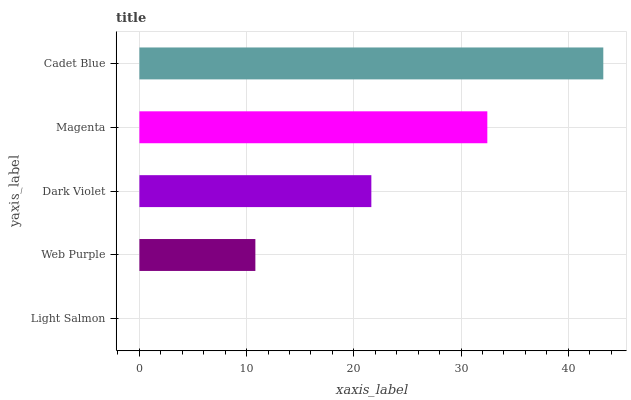Is Light Salmon the minimum?
Answer yes or no. Yes. Is Cadet Blue the maximum?
Answer yes or no. Yes. Is Web Purple the minimum?
Answer yes or no. No. Is Web Purple the maximum?
Answer yes or no. No. Is Web Purple greater than Light Salmon?
Answer yes or no. Yes. Is Light Salmon less than Web Purple?
Answer yes or no. Yes. Is Light Salmon greater than Web Purple?
Answer yes or no. No. Is Web Purple less than Light Salmon?
Answer yes or no. No. Is Dark Violet the high median?
Answer yes or no. Yes. Is Dark Violet the low median?
Answer yes or no. Yes. Is Light Salmon the high median?
Answer yes or no. No. Is Cadet Blue the low median?
Answer yes or no. No. 